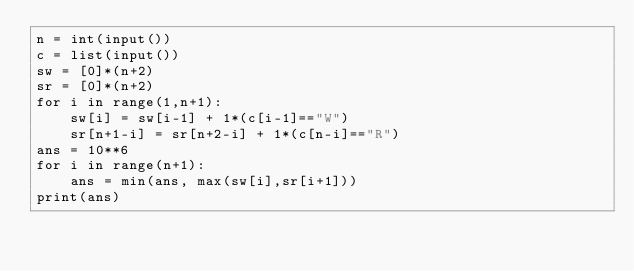Convert code to text. <code><loc_0><loc_0><loc_500><loc_500><_Python_>n = int(input())
c = list(input())
sw = [0]*(n+2)
sr = [0]*(n+2)
for i in range(1,n+1):
    sw[i] = sw[i-1] + 1*(c[i-1]=="W")
    sr[n+1-i] = sr[n+2-i] + 1*(c[n-i]=="R")
ans = 10**6
for i in range(n+1):
    ans = min(ans, max(sw[i],sr[i+1]))
print(ans)</code> 